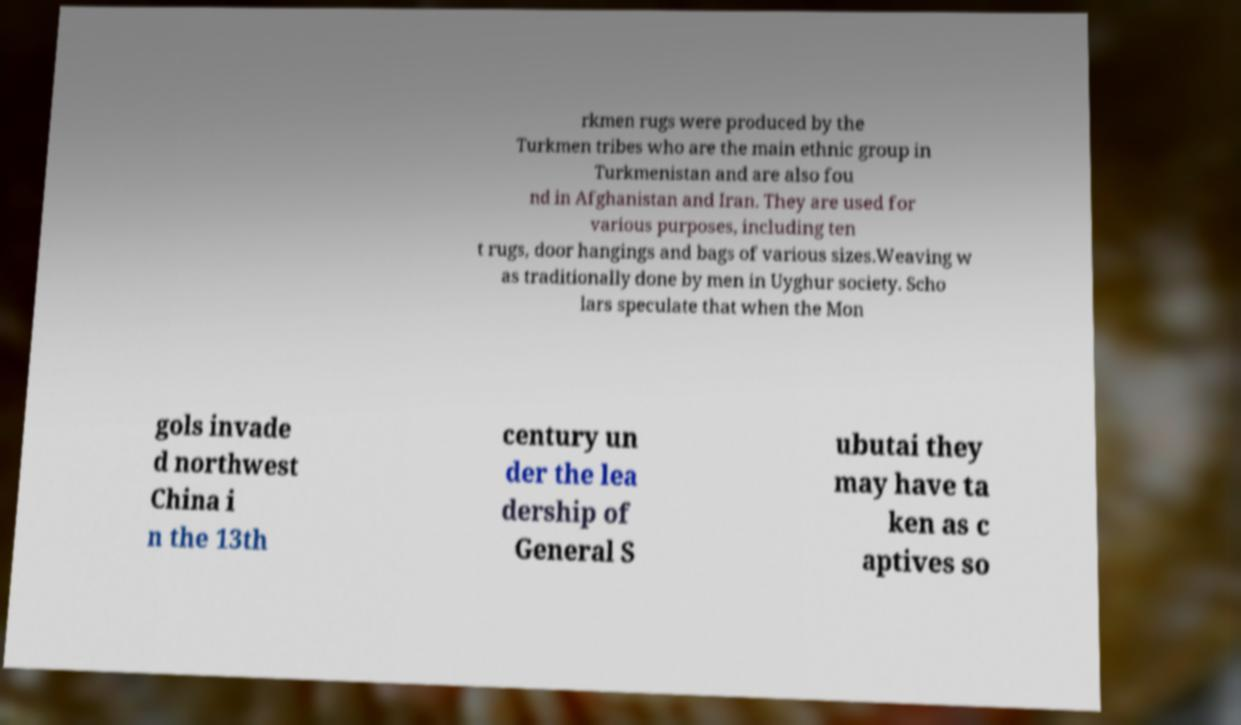Please read and relay the text visible in this image. What does it say? rkmen rugs were produced by the Turkmen tribes who are the main ethnic group in Turkmenistan and are also fou nd in Afghanistan and Iran. They are used for various purposes, including ten t rugs, door hangings and bags of various sizes.Weaving w as traditionally done by men in Uyghur society. Scho lars speculate that when the Mon gols invade d northwest China i n the 13th century un der the lea dership of General S ubutai they may have ta ken as c aptives so 